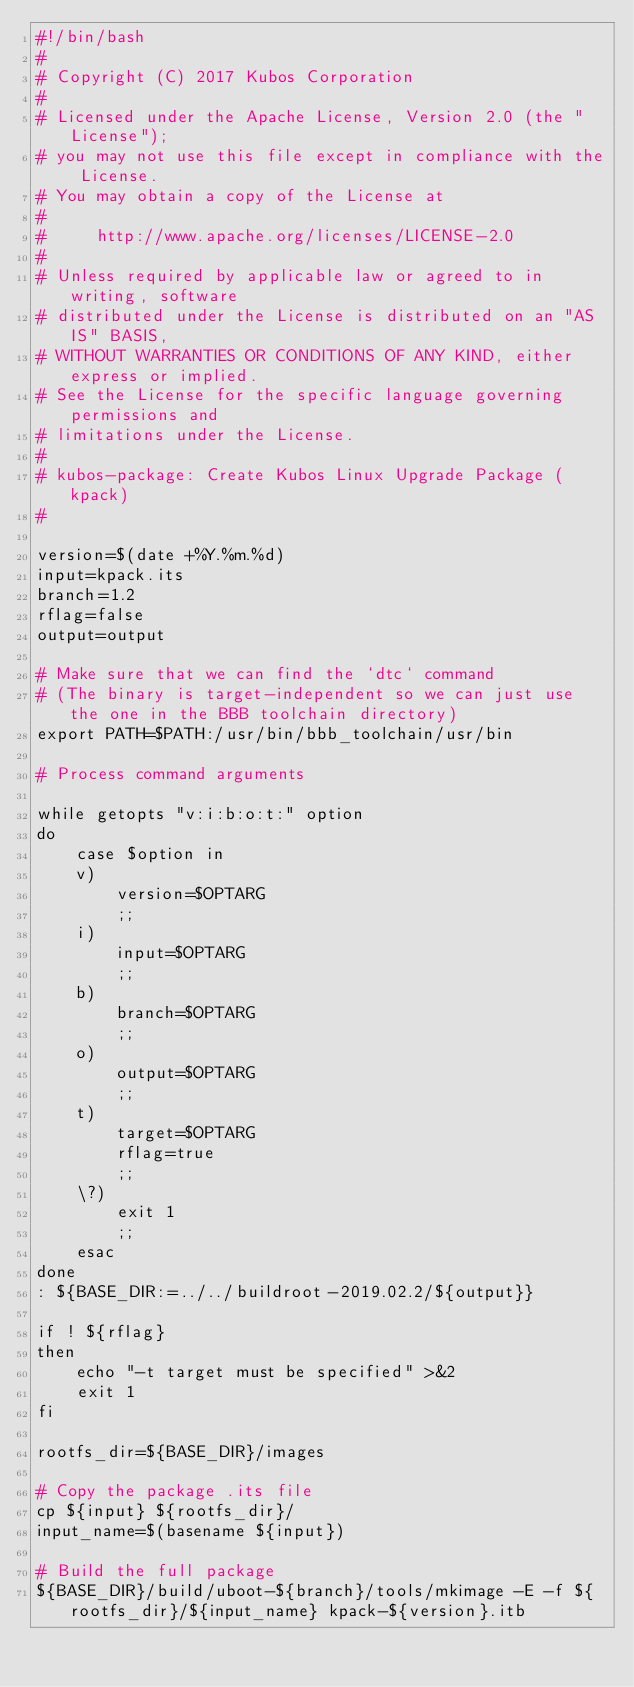Convert code to text. <code><loc_0><loc_0><loc_500><loc_500><_Bash_>#!/bin/bash
#
# Copyright (C) 2017 Kubos Corporation
#
# Licensed under the Apache License, Version 2.0 (the "License");
# you may not use this file except in compliance with the License.
# You may obtain a copy of the License at
#
#     http://www.apache.org/licenses/LICENSE-2.0
#
# Unless required by applicable law or agreed to in writing, software
# distributed under the License is distributed on an "AS IS" BASIS,
# WITHOUT WARRANTIES OR CONDITIONS OF ANY KIND, either express or implied.
# See the License for the specific language governing permissions and
# limitations under the License.
#
# kubos-package: Create Kubos Linux Upgrade Package (kpack)
#
 
version=$(date +%Y.%m.%d)
input=kpack.its
branch=1.2
rflag=false
output=output

# Make sure that we can find the `dtc` command
# (The binary is target-independent so we can just use the one in the BBB toolchain directory)
export PATH=$PATH:/usr/bin/bbb_toolchain/usr/bin

# Process command arguments

while getopts "v:i:b:o:t:" option
do
    case $option in
	v)
	    version=$OPTARG
	    ;;
	i)
	    input=$OPTARG
	    ;;
	b)
	    branch=$OPTARG
	    ;;
	o)
	    output=$OPTARG
	    ;;
	t)
	    target=$OPTARG
	    rflag=true
	    ;;
	\?)
	    exit 1
	    ;;
    esac
done
: ${BASE_DIR:=../../buildroot-2019.02.2/${output}}

if ! ${rflag}
then
    echo "-t target must be specified" >&2
    exit 1
fi

rootfs_dir=${BASE_DIR}/images

# Copy the package .its file
cp ${input} ${rootfs_dir}/
input_name=$(basename ${input})

# Build the full package
${BASE_DIR}/build/uboot-${branch}/tools/mkimage -E -f ${rootfs_dir}/${input_name} kpack-${version}.itb


</code> 